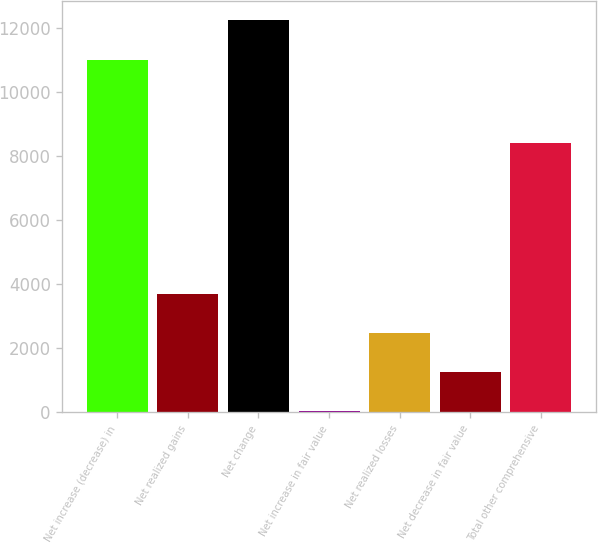<chart> <loc_0><loc_0><loc_500><loc_500><bar_chart><fcel>Net increase (decrease) in<fcel>Net realized gains<fcel>Net change<fcel>Net increase in fair value<fcel>Net realized losses<fcel>Net decrease in fair value<fcel>Total other comprehensive<nl><fcel>10989<fcel>3694.4<fcel>12240<fcel>32<fcel>2473.6<fcel>1252.8<fcel>8400<nl></chart> 